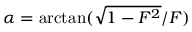Convert formula to latex. <formula><loc_0><loc_0><loc_500><loc_500>\alpha = \arctan ( \sqrt { 1 - F ^ { 2 } } / F )</formula> 